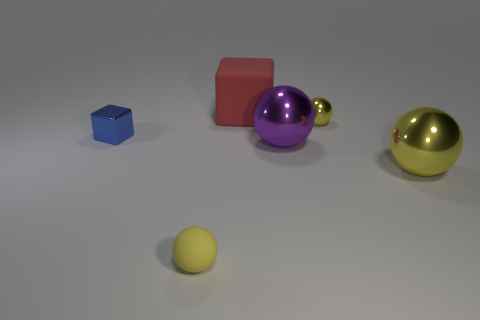Subtract all red blocks. How many yellow spheres are left? 3 Subtract all gray spheres. Subtract all green cubes. How many spheres are left? 4 Add 1 red cubes. How many objects exist? 7 Subtract all balls. How many objects are left? 2 Subtract all things. Subtract all cyan rubber balls. How many objects are left? 0 Add 3 big red matte blocks. How many big red matte blocks are left? 4 Add 6 tiny blue blocks. How many tiny blue blocks exist? 7 Subtract 0 cyan cylinders. How many objects are left? 6 